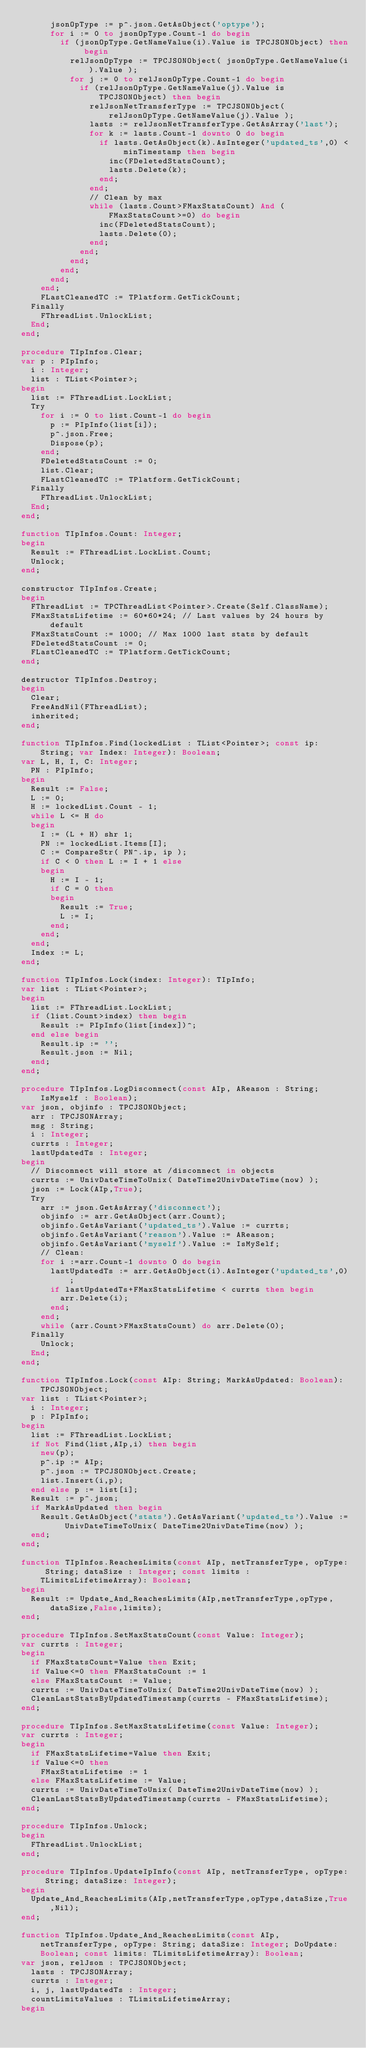<code> <loc_0><loc_0><loc_500><loc_500><_Pascal_>      jsonOpType := p^.json.GetAsObject('optype');
      for i := 0 to jsonOpType.Count-1 do begin
        if (jsonOpType.GetNameValue(i).Value is TPCJSONObject) then begin
          relJsonOpType := TPCJSONObject( jsonOpType.GetNameValue(i).Value );
          for j := 0 to relJsonOpType.Count-1 do begin
            if (relJsonOpType.GetNameValue(j).Value is TPCJSONObject) then begin
              relJsonNetTransferType := TPCJSONObject( relJsonOpType.GetNameValue(j).Value );
              lasts := relJsonNetTransferType.GetAsArray('last');
              for k := lasts.Count-1 downto 0 do begin
                if lasts.GetAsObject(k).AsInteger('updated_ts',0) < minTimestamp then begin
                  inc(FDeletedStatsCount);
                  lasts.Delete(k);
                end;
              end;
              // Clean by max
              while (lasts.Count>FMaxStatsCount) And (FMaxStatsCount>=0) do begin
                inc(FDeletedStatsCount);
                lasts.Delete(0);
              end;
            end;
          end;
        end;
      end;
    end;
    FLastCleanedTC := TPlatform.GetTickCount;
  Finally
    FThreadList.UnlockList;
  End;
end;

procedure TIpInfos.Clear;
var p : PIpInfo;
  i : Integer;
  list : TList<Pointer>;
begin
  list := FThreadList.LockList;
  Try
    for i := 0 to list.Count-1 do begin
      p := PIpInfo(list[i]);
      p^.json.Free;
      Dispose(p);
    end;
    FDeletedStatsCount := 0;
    list.Clear;
    FLastCleanedTC := TPlatform.GetTickCount;
  Finally
    FThreadList.UnlockList;
  End;
end;

function TIpInfos.Count: Integer;
begin
  Result := FThreadList.LockList.Count;
  Unlock;
end;

constructor TIpInfos.Create;
begin
  FThreadList := TPCThreadList<Pointer>.Create(Self.ClassName);
  FMaxStatsLifetime := 60*60*24; // Last values by 24 hours by default
  FMaxStatsCount := 1000; // Max 1000 last stats by default
  FDeletedStatsCount := 0;
  FLastCleanedTC := TPlatform.GetTickCount;
end;

destructor TIpInfos.Destroy;
begin
  Clear;
  FreeAndNil(FThreadList);
  inherited;
end;

function TIpInfos.Find(lockedList : TList<Pointer>; const ip: String; var Index: Integer): Boolean;
var L, H, I, C: Integer;
  PN : PIpInfo;
begin
  Result := False;
  L := 0;
  H := lockedList.Count - 1;
  while L <= H do
  begin
    I := (L + H) shr 1;
    PN := lockedList.Items[I];
    C := CompareStr( PN^.ip, ip );
    if C < 0 then L := I + 1 else
    begin
      H := I - 1;
      if C = 0 then
      begin
        Result := True;
        L := I;
      end;
    end;
  end;
  Index := L;
end;

function TIpInfos.Lock(index: Integer): TIpInfo;
var list : TList<Pointer>;
begin
  list := FThreadList.LockList;
  if (list.Count>index) then begin
    Result := PIpInfo(list[index])^;
  end else begin
    Result.ip := '';
    Result.json := Nil;
  end;
end;

procedure TIpInfos.LogDisconnect(const AIp, AReason : String; IsMyself : Boolean);
var json, objinfo : TPCJSONObject;
  arr : TPCJSONArray;
  msg : String;
  i : Integer;
  currts : Integer;
  lastUpdatedTs : Integer;
begin
  // Disconnect will store at /disconnect in objects
  currts := UnivDateTimeToUnix( DateTime2UnivDateTime(now) );
  json := Lock(AIp,True);
  Try
    arr := json.GetAsArray('disconnect');
    objinfo := arr.GetAsObject(arr.Count);
    objinfo.GetAsVariant('updated_ts').Value := currts;
    objinfo.GetAsVariant('reason').Value := AReason;
    objinfo.GetAsVariant('myself').Value := IsMySelf;
    // Clean:
    for i :=arr.Count-1 downto 0 do begin
      lastUpdatedTs := arr.GetAsObject(i).AsInteger('updated_ts',0);
      if lastUpdatedTs+FMaxStatsLifetime < currts then begin
        arr.Delete(i);
      end;
    end;
    while (arr.Count>FMaxStatsCount) do arr.Delete(0);
  Finally
    Unlock;
  End;
end;

function TIpInfos.Lock(const AIp: String; MarkAsUpdated: Boolean): TPCJSONObject;
var list : TList<Pointer>;
  i : Integer;
  p : PIpInfo;
begin
  list := FThreadList.LockList;
  if Not Find(list,AIp,i) then begin
    new(p);
    p^.ip := AIp;
    p^.json := TPCJSONObject.Create;
    list.Insert(i,p);
  end else p := list[i];
  Result := p^.json;
  if MarkAsUpdated then begin
    Result.GetAsObject('stats').GetAsVariant('updated_ts').Value := UnivDateTimeToUnix( DateTime2UnivDateTime(now) );
  end;
end;

function TIpInfos.ReachesLimits(const AIp, netTransferType, opType: String; dataSize : Integer; const limits : TLimitsLifetimeArray): Boolean;
begin
  Result := Update_And_ReachesLimits(AIp,netTransferType,opType,dataSize,False,limits);
end;

procedure TIpInfos.SetMaxStatsCount(const Value: Integer);
var currts : Integer;
begin
  if FMaxStatsCount=Value then Exit;
  if Value<=0 then FMaxStatsCount := 1
  else FMaxStatsCount := Value;
  currts := UnivDateTimeToUnix( DateTime2UnivDateTime(now) );
  CleanLastStatsByUpdatedTimestamp(currts - FMaxStatsLifetime);
end;

procedure TIpInfos.SetMaxStatsLifetime(const Value: Integer);
var currts : Integer;
begin
  if FMaxStatsLifetime=Value then Exit;
  if Value<=0 then
    FMaxStatsLifetime := 1
  else FMaxStatsLifetime := Value;
  currts := UnivDateTimeToUnix( DateTime2UnivDateTime(now) );
  CleanLastStatsByUpdatedTimestamp(currts - FMaxStatsLifetime);
end;

procedure TIpInfos.Unlock;
begin
  FThreadList.UnlockList;
end;

procedure TIpInfos.UpdateIpInfo(const AIp, netTransferType, opType: String; dataSize: Integer);
begin
  Update_And_ReachesLimits(AIp,netTransferType,opType,dataSize,True,Nil);
end;

function TIpInfos.Update_And_ReachesLimits(const AIp, netTransferType, opType: String; dataSize: Integer; DoUpdate: Boolean; const limits: TLimitsLifetimeArray): Boolean;
var json, relJson : TPCJSONObject;
  lasts : TPCJSONArray;
  currts : Integer;
  i, j, lastUpdatedTs : Integer;
  countLimitsValues : TLimitsLifetimeArray;
begin</code> 